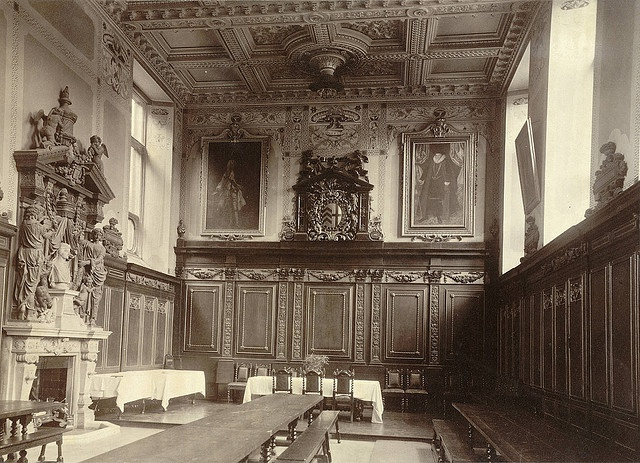Describe the objects in this image and their specific colors. I can see dining table in gray and tan tones, dining table in gray, black, and maroon tones, dining table in gray, beige, and tan tones, bench in gray and darkgray tones, and dining table in gray, beige, and tan tones in this image. 